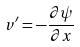<formula> <loc_0><loc_0><loc_500><loc_500>v ^ { \prime } = - \frac { \partial \psi } { \partial x }</formula> 